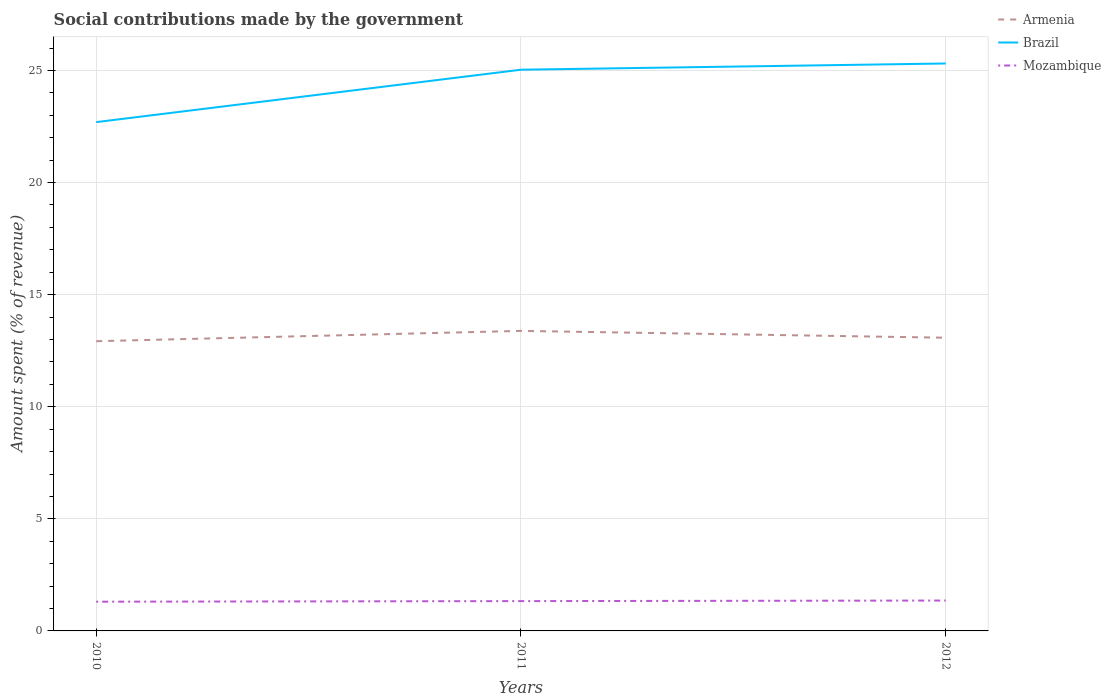How many different coloured lines are there?
Your response must be concise. 3. Does the line corresponding to Brazil intersect with the line corresponding to Armenia?
Keep it short and to the point. No. Is the number of lines equal to the number of legend labels?
Your answer should be compact. Yes. Across all years, what is the maximum amount spent (in %) on social contributions in Mozambique?
Give a very brief answer. 1.3. What is the total amount spent (in %) on social contributions in Armenia in the graph?
Make the answer very short. -0.46. What is the difference between the highest and the second highest amount spent (in %) on social contributions in Armenia?
Your answer should be very brief. 0.46. Is the amount spent (in %) on social contributions in Brazil strictly greater than the amount spent (in %) on social contributions in Armenia over the years?
Offer a terse response. No. Are the values on the major ticks of Y-axis written in scientific E-notation?
Ensure brevity in your answer.  No. Does the graph contain any zero values?
Your response must be concise. No. Does the graph contain grids?
Ensure brevity in your answer.  Yes. Where does the legend appear in the graph?
Provide a short and direct response. Top right. How many legend labels are there?
Ensure brevity in your answer.  3. How are the legend labels stacked?
Ensure brevity in your answer.  Vertical. What is the title of the graph?
Provide a succinct answer. Social contributions made by the government. Does "Central African Republic" appear as one of the legend labels in the graph?
Give a very brief answer. No. What is the label or title of the X-axis?
Keep it short and to the point. Years. What is the label or title of the Y-axis?
Provide a succinct answer. Amount spent (% of revenue). What is the Amount spent (% of revenue) in Armenia in 2010?
Ensure brevity in your answer.  12.92. What is the Amount spent (% of revenue) in Brazil in 2010?
Offer a terse response. 22.7. What is the Amount spent (% of revenue) of Mozambique in 2010?
Make the answer very short. 1.3. What is the Amount spent (% of revenue) in Armenia in 2011?
Make the answer very short. 13.38. What is the Amount spent (% of revenue) in Brazil in 2011?
Make the answer very short. 25.03. What is the Amount spent (% of revenue) in Mozambique in 2011?
Your answer should be very brief. 1.33. What is the Amount spent (% of revenue) of Armenia in 2012?
Provide a short and direct response. 13.08. What is the Amount spent (% of revenue) in Brazil in 2012?
Give a very brief answer. 25.31. What is the Amount spent (% of revenue) in Mozambique in 2012?
Your response must be concise. 1.36. Across all years, what is the maximum Amount spent (% of revenue) in Armenia?
Give a very brief answer. 13.38. Across all years, what is the maximum Amount spent (% of revenue) of Brazil?
Keep it short and to the point. 25.31. Across all years, what is the maximum Amount spent (% of revenue) in Mozambique?
Keep it short and to the point. 1.36. Across all years, what is the minimum Amount spent (% of revenue) of Armenia?
Provide a succinct answer. 12.92. Across all years, what is the minimum Amount spent (% of revenue) in Brazil?
Offer a very short reply. 22.7. Across all years, what is the minimum Amount spent (% of revenue) in Mozambique?
Offer a very short reply. 1.3. What is the total Amount spent (% of revenue) in Armenia in the graph?
Offer a very short reply. 39.39. What is the total Amount spent (% of revenue) of Brazil in the graph?
Provide a short and direct response. 73.04. What is the total Amount spent (% of revenue) in Mozambique in the graph?
Provide a short and direct response. 3.99. What is the difference between the Amount spent (% of revenue) of Armenia in 2010 and that in 2011?
Give a very brief answer. -0.46. What is the difference between the Amount spent (% of revenue) in Brazil in 2010 and that in 2011?
Your answer should be compact. -2.34. What is the difference between the Amount spent (% of revenue) of Mozambique in 2010 and that in 2011?
Make the answer very short. -0.03. What is the difference between the Amount spent (% of revenue) of Armenia in 2010 and that in 2012?
Your answer should be very brief. -0.16. What is the difference between the Amount spent (% of revenue) of Brazil in 2010 and that in 2012?
Make the answer very short. -2.62. What is the difference between the Amount spent (% of revenue) in Mozambique in 2010 and that in 2012?
Offer a terse response. -0.05. What is the difference between the Amount spent (% of revenue) of Armenia in 2011 and that in 2012?
Give a very brief answer. 0.3. What is the difference between the Amount spent (% of revenue) in Brazil in 2011 and that in 2012?
Your answer should be compact. -0.28. What is the difference between the Amount spent (% of revenue) in Mozambique in 2011 and that in 2012?
Your answer should be compact. -0.03. What is the difference between the Amount spent (% of revenue) of Armenia in 2010 and the Amount spent (% of revenue) of Brazil in 2011?
Keep it short and to the point. -12.11. What is the difference between the Amount spent (% of revenue) in Armenia in 2010 and the Amount spent (% of revenue) in Mozambique in 2011?
Make the answer very short. 11.59. What is the difference between the Amount spent (% of revenue) in Brazil in 2010 and the Amount spent (% of revenue) in Mozambique in 2011?
Offer a very short reply. 21.37. What is the difference between the Amount spent (% of revenue) in Armenia in 2010 and the Amount spent (% of revenue) in Brazil in 2012?
Offer a terse response. -12.39. What is the difference between the Amount spent (% of revenue) in Armenia in 2010 and the Amount spent (% of revenue) in Mozambique in 2012?
Provide a succinct answer. 11.57. What is the difference between the Amount spent (% of revenue) of Brazil in 2010 and the Amount spent (% of revenue) of Mozambique in 2012?
Your answer should be very brief. 21.34. What is the difference between the Amount spent (% of revenue) of Armenia in 2011 and the Amount spent (% of revenue) of Brazil in 2012?
Your answer should be very brief. -11.93. What is the difference between the Amount spent (% of revenue) of Armenia in 2011 and the Amount spent (% of revenue) of Mozambique in 2012?
Ensure brevity in your answer.  12.03. What is the difference between the Amount spent (% of revenue) of Brazil in 2011 and the Amount spent (% of revenue) of Mozambique in 2012?
Your response must be concise. 23.68. What is the average Amount spent (% of revenue) of Armenia per year?
Your answer should be very brief. 13.13. What is the average Amount spent (% of revenue) in Brazil per year?
Make the answer very short. 24.35. What is the average Amount spent (% of revenue) of Mozambique per year?
Your answer should be compact. 1.33. In the year 2010, what is the difference between the Amount spent (% of revenue) of Armenia and Amount spent (% of revenue) of Brazil?
Keep it short and to the point. -9.77. In the year 2010, what is the difference between the Amount spent (% of revenue) in Armenia and Amount spent (% of revenue) in Mozambique?
Give a very brief answer. 11.62. In the year 2010, what is the difference between the Amount spent (% of revenue) in Brazil and Amount spent (% of revenue) in Mozambique?
Your answer should be compact. 21.39. In the year 2011, what is the difference between the Amount spent (% of revenue) of Armenia and Amount spent (% of revenue) of Brazil?
Make the answer very short. -11.65. In the year 2011, what is the difference between the Amount spent (% of revenue) in Armenia and Amount spent (% of revenue) in Mozambique?
Ensure brevity in your answer.  12.05. In the year 2011, what is the difference between the Amount spent (% of revenue) of Brazil and Amount spent (% of revenue) of Mozambique?
Offer a terse response. 23.71. In the year 2012, what is the difference between the Amount spent (% of revenue) of Armenia and Amount spent (% of revenue) of Brazil?
Your answer should be compact. -12.23. In the year 2012, what is the difference between the Amount spent (% of revenue) in Armenia and Amount spent (% of revenue) in Mozambique?
Provide a short and direct response. 11.72. In the year 2012, what is the difference between the Amount spent (% of revenue) of Brazil and Amount spent (% of revenue) of Mozambique?
Your answer should be compact. 23.96. What is the ratio of the Amount spent (% of revenue) in Armenia in 2010 to that in 2011?
Your answer should be compact. 0.97. What is the ratio of the Amount spent (% of revenue) of Brazil in 2010 to that in 2011?
Your answer should be compact. 0.91. What is the ratio of the Amount spent (% of revenue) in Mozambique in 2010 to that in 2011?
Your answer should be compact. 0.98. What is the ratio of the Amount spent (% of revenue) of Armenia in 2010 to that in 2012?
Your answer should be compact. 0.99. What is the ratio of the Amount spent (% of revenue) of Brazil in 2010 to that in 2012?
Ensure brevity in your answer.  0.9. What is the ratio of the Amount spent (% of revenue) in Mozambique in 2010 to that in 2012?
Ensure brevity in your answer.  0.96. What is the ratio of the Amount spent (% of revenue) in Armenia in 2011 to that in 2012?
Provide a short and direct response. 1.02. What is the ratio of the Amount spent (% of revenue) of Brazil in 2011 to that in 2012?
Your answer should be compact. 0.99. What is the ratio of the Amount spent (% of revenue) of Mozambique in 2011 to that in 2012?
Give a very brief answer. 0.98. What is the difference between the highest and the second highest Amount spent (% of revenue) of Armenia?
Give a very brief answer. 0.3. What is the difference between the highest and the second highest Amount spent (% of revenue) of Brazil?
Offer a very short reply. 0.28. What is the difference between the highest and the second highest Amount spent (% of revenue) of Mozambique?
Keep it short and to the point. 0.03. What is the difference between the highest and the lowest Amount spent (% of revenue) in Armenia?
Provide a short and direct response. 0.46. What is the difference between the highest and the lowest Amount spent (% of revenue) in Brazil?
Your answer should be compact. 2.62. What is the difference between the highest and the lowest Amount spent (% of revenue) in Mozambique?
Keep it short and to the point. 0.05. 